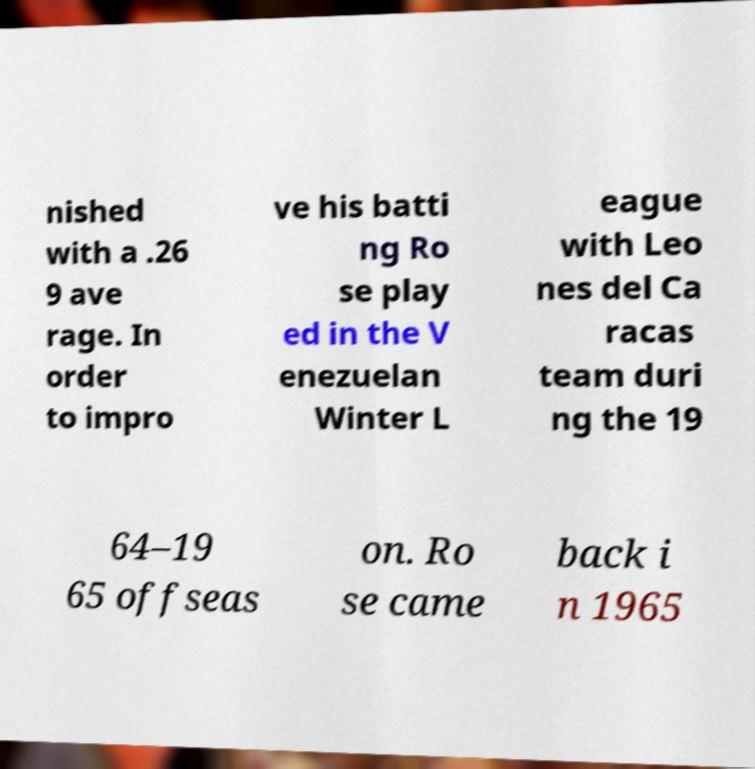For documentation purposes, I need the text within this image transcribed. Could you provide that? nished with a .26 9 ave rage. In order to impro ve his batti ng Ro se play ed in the V enezuelan Winter L eague with Leo nes del Ca racas team duri ng the 19 64–19 65 offseas on. Ro se came back i n 1965 